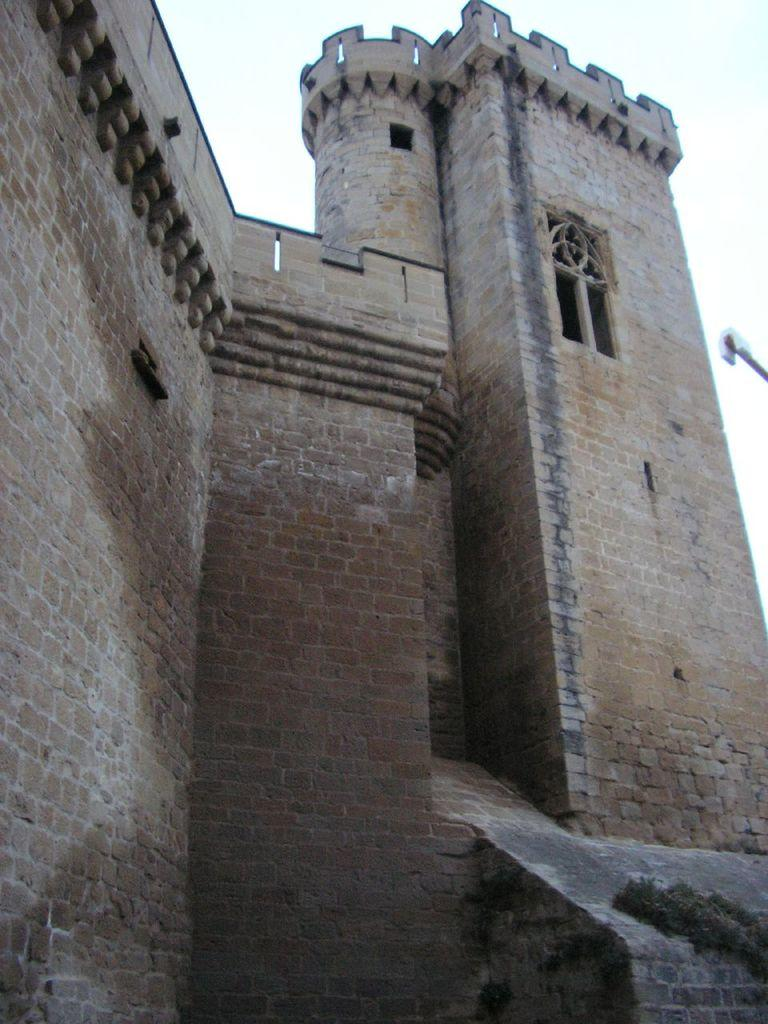What type of structure is present in the image? There is a fort in the image. What can be seen in the background of the image? The sky is visible in the background of the image. Can you touch the appliance in the image? There is no appliance present in the image. What type of sink is visible in the image? There is no sink present in the image. 